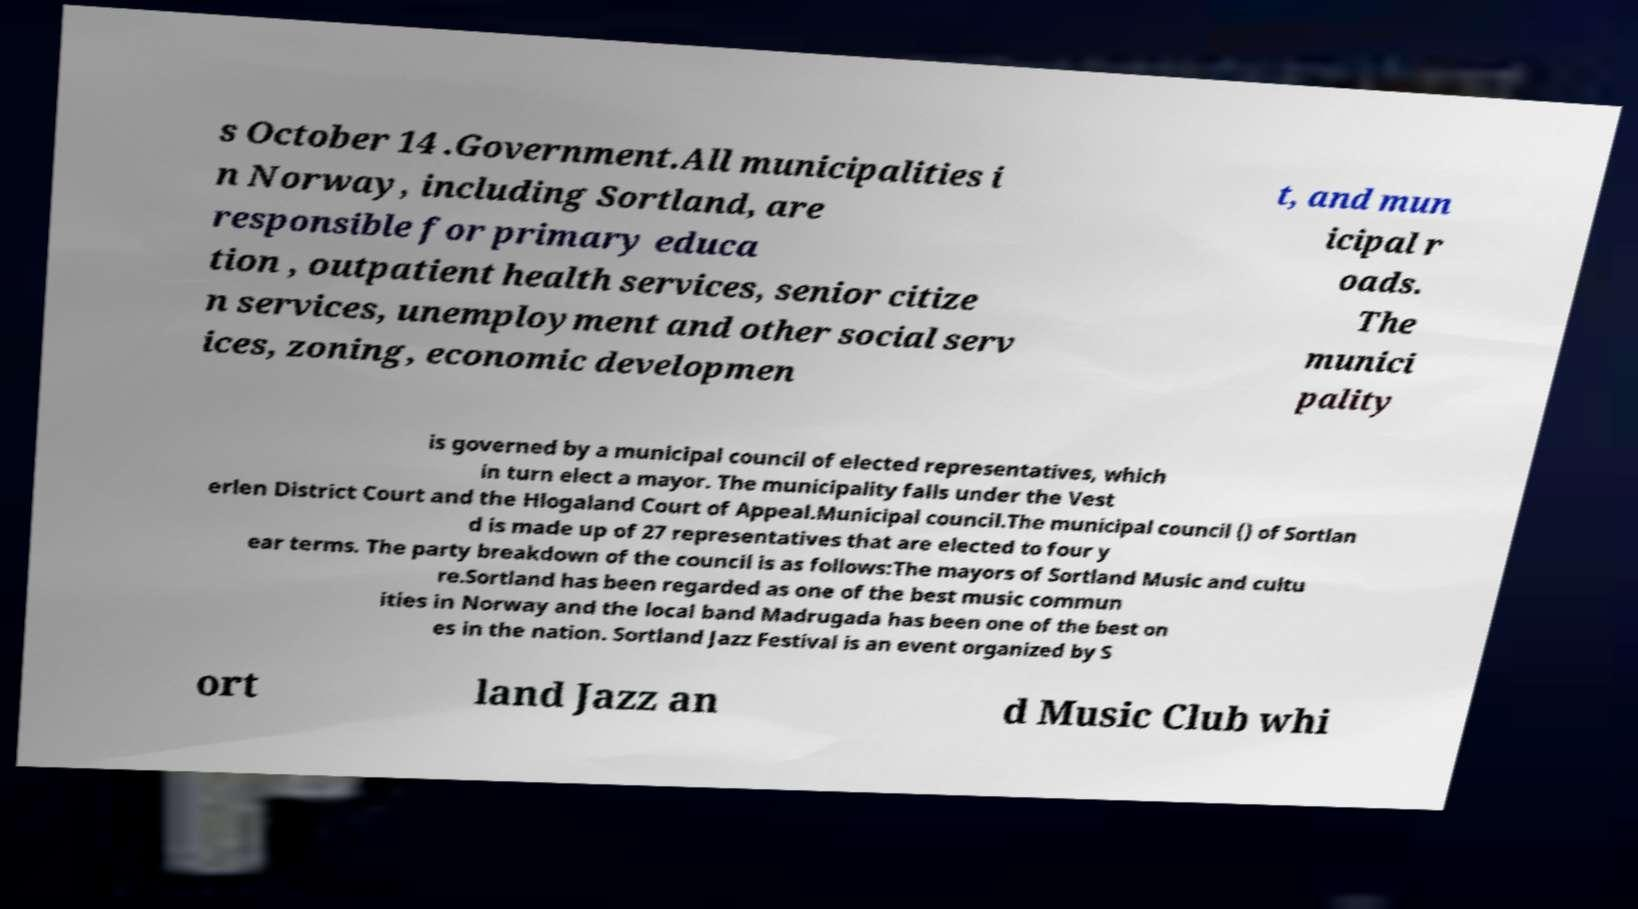Can you accurately transcribe the text from the provided image for me? s October 14 .Government.All municipalities i n Norway, including Sortland, are responsible for primary educa tion , outpatient health services, senior citize n services, unemployment and other social serv ices, zoning, economic developmen t, and mun icipal r oads. The munici pality is governed by a municipal council of elected representatives, which in turn elect a mayor. The municipality falls under the Vest erlen District Court and the Hlogaland Court of Appeal.Municipal council.The municipal council () of Sortlan d is made up of 27 representatives that are elected to four y ear terms. The party breakdown of the council is as follows:The mayors of Sortland Music and cultu re.Sortland has been regarded as one of the best music commun ities in Norway and the local band Madrugada has been one of the best on es in the nation. Sortland Jazz Festival is an event organized by S ort land Jazz an d Music Club whi 